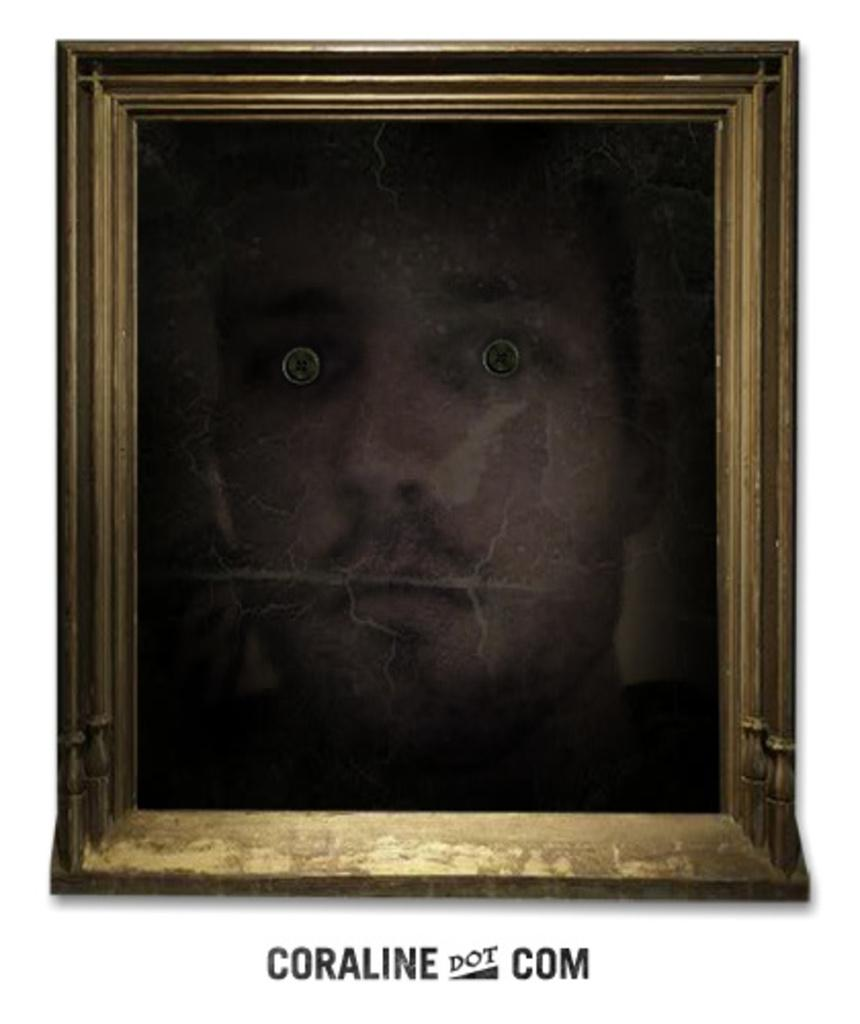Provide a one-sentence caption for the provided image. A framed portrait of a man with strange eyes is set above the words "Coraline dot com". 